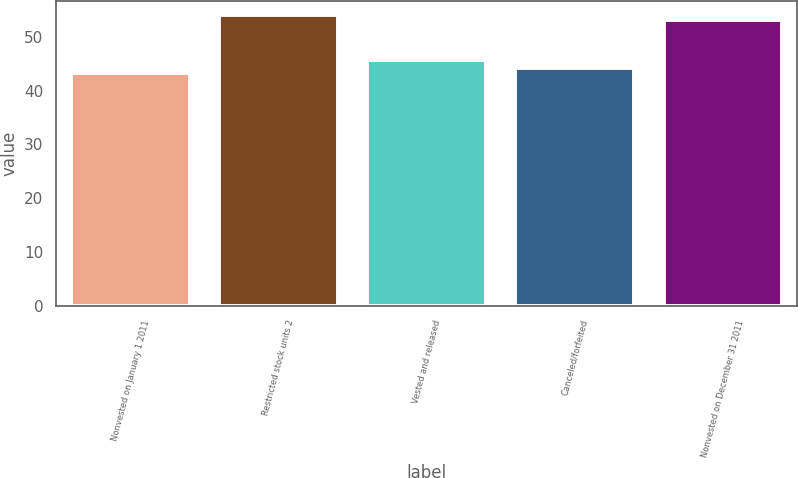Convert chart to OTSL. <chart><loc_0><loc_0><loc_500><loc_500><bar_chart><fcel>Nonvested on January 1 2011<fcel>Restricted stock units 2<fcel>Vested and released<fcel>Canceled/forfeited<fcel>Nonvested on December 31 2011<nl><fcel>43.29<fcel>54.03<fcel>45.72<fcel>44.27<fcel>53.05<nl></chart> 